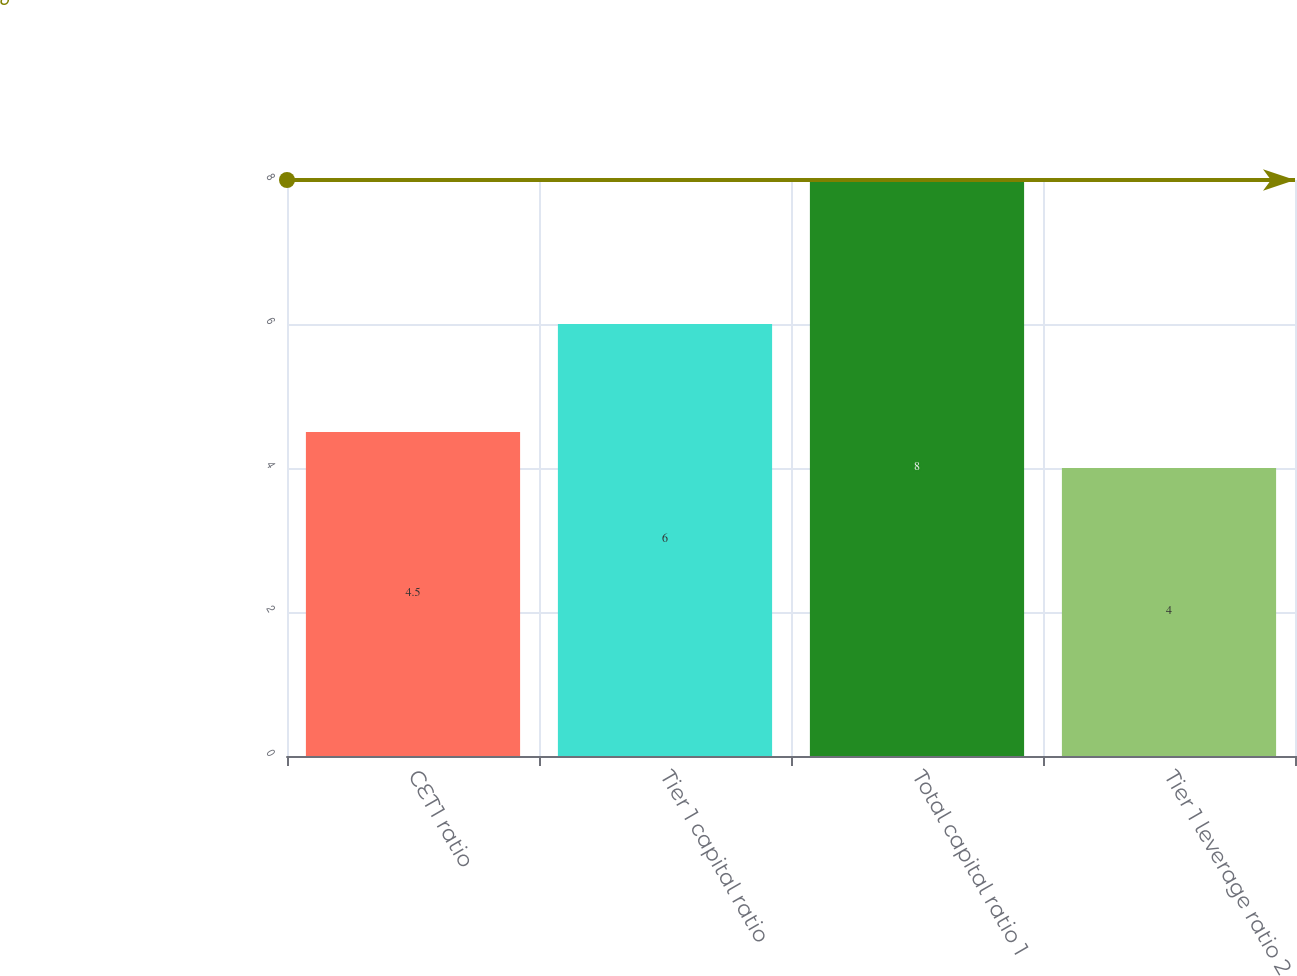<chart> <loc_0><loc_0><loc_500><loc_500><bar_chart><fcel>CET1 ratio<fcel>Tier 1 capital ratio<fcel>Total capital ratio 1<fcel>Tier 1 leverage ratio 2<nl><fcel>4.5<fcel>6<fcel>8<fcel>4<nl></chart> 